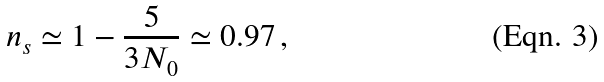Convert formula to latex. <formula><loc_0><loc_0><loc_500><loc_500>n _ { s } \simeq 1 - \frac { 5 } { 3 N _ { 0 } } \simeq 0 . 9 7 \, ,</formula> 